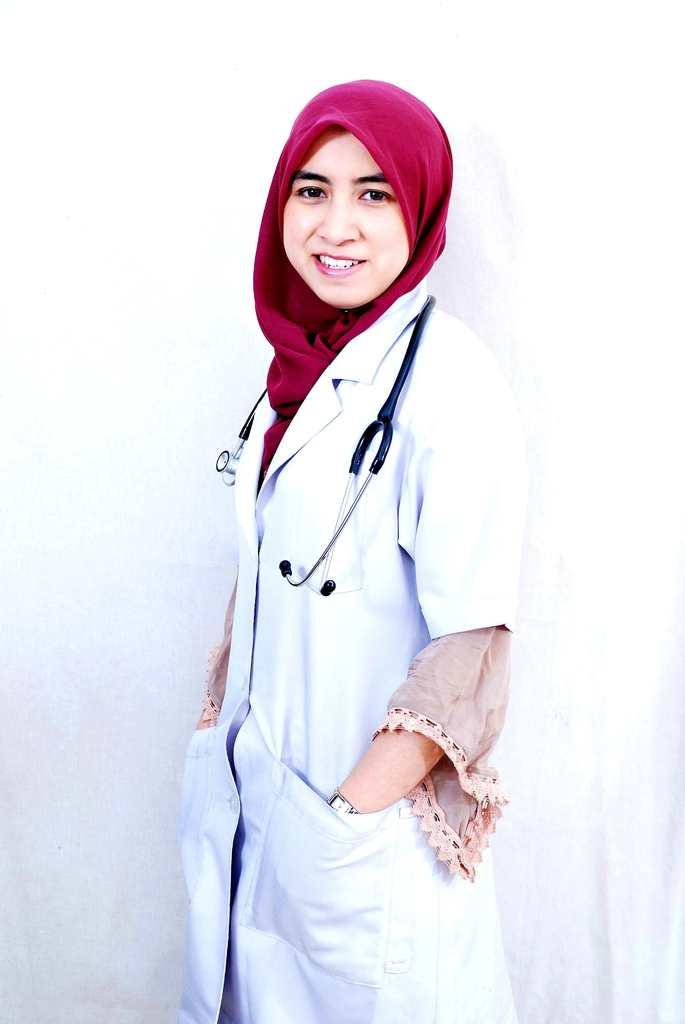What is the profession of the person in the image? There is a doctor in the image. What is the doctor wearing that indicates their profession? The doctor is wearing a white coat. Are there any other notable accessories the doctor is wearing? The doctor is wearing a red scarf. What medical tool is visible on the doctor's shoulder? There is a stethoscope on the doctor's shoulder. What type of key is the doctor holding in the image? There is no key present in the image. How many branches are visible on the doctor's tree in the image? There is no tree or branches present in the image. 